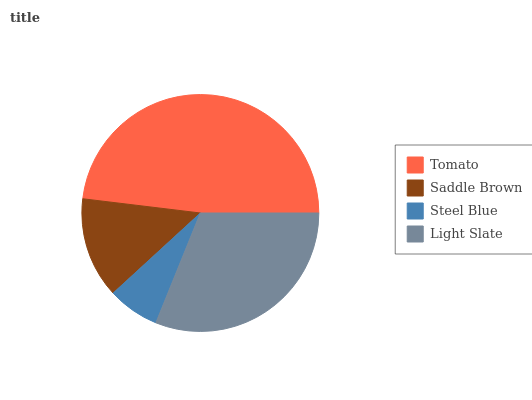Is Steel Blue the minimum?
Answer yes or no. Yes. Is Tomato the maximum?
Answer yes or no. Yes. Is Saddle Brown the minimum?
Answer yes or no. No. Is Saddle Brown the maximum?
Answer yes or no. No. Is Tomato greater than Saddle Brown?
Answer yes or no. Yes. Is Saddle Brown less than Tomato?
Answer yes or no. Yes. Is Saddle Brown greater than Tomato?
Answer yes or no. No. Is Tomato less than Saddle Brown?
Answer yes or no. No. Is Light Slate the high median?
Answer yes or no. Yes. Is Saddle Brown the low median?
Answer yes or no. Yes. Is Saddle Brown the high median?
Answer yes or no. No. Is Light Slate the low median?
Answer yes or no. No. 